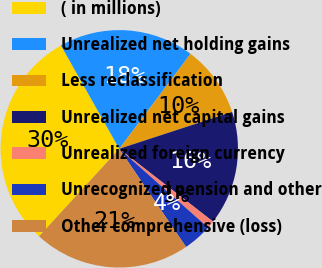Convert chart to OTSL. <chart><loc_0><loc_0><loc_500><loc_500><pie_chart><fcel>( in millions)<fcel>Unrealized net holding gains<fcel>Less reclassification<fcel>Unrealized net capital gains<fcel>Unrealized foreign currency<fcel>Unrecognized pension and other<fcel>Other comprehensive (loss)<nl><fcel>30.01%<fcel>18.42%<fcel>9.73%<fcel>15.53%<fcel>1.04%<fcel>3.94%<fcel>21.32%<nl></chart> 